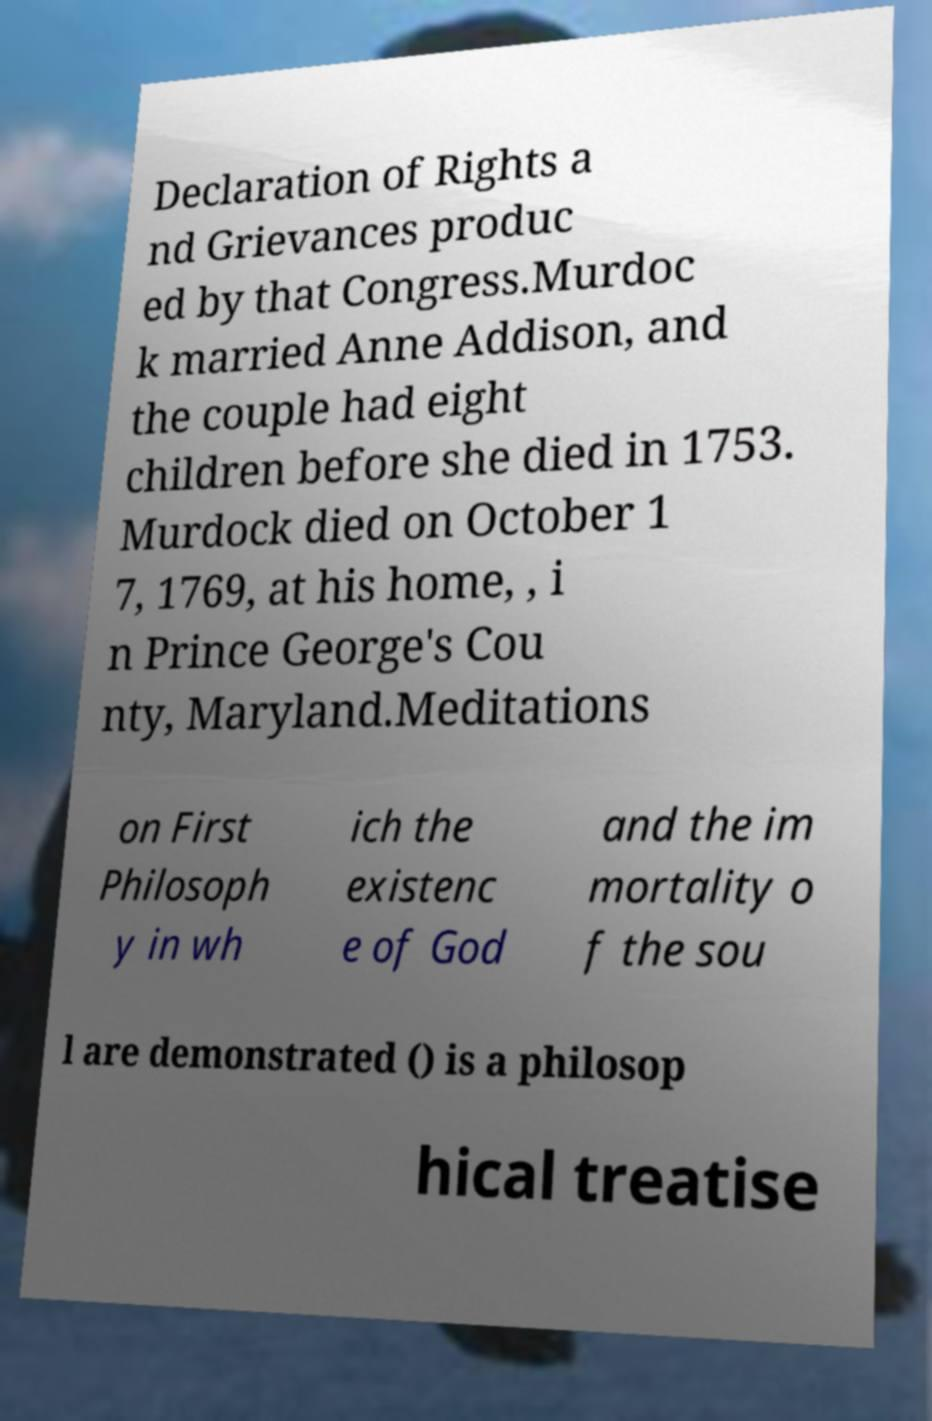Can you accurately transcribe the text from the provided image for me? Declaration of Rights a nd Grievances produc ed by that Congress.Murdoc k married Anne Addison, and the couple had eight children before she died in 1753. Murdock died on October 1 7, 1769, at his home, , i n Prince George's Cou nty, Maryland.Meditations on First Philosoph y in wh ich the existenc e of God and the im mortality o f the sou l are demonstrated () is a philosop hical treatise 